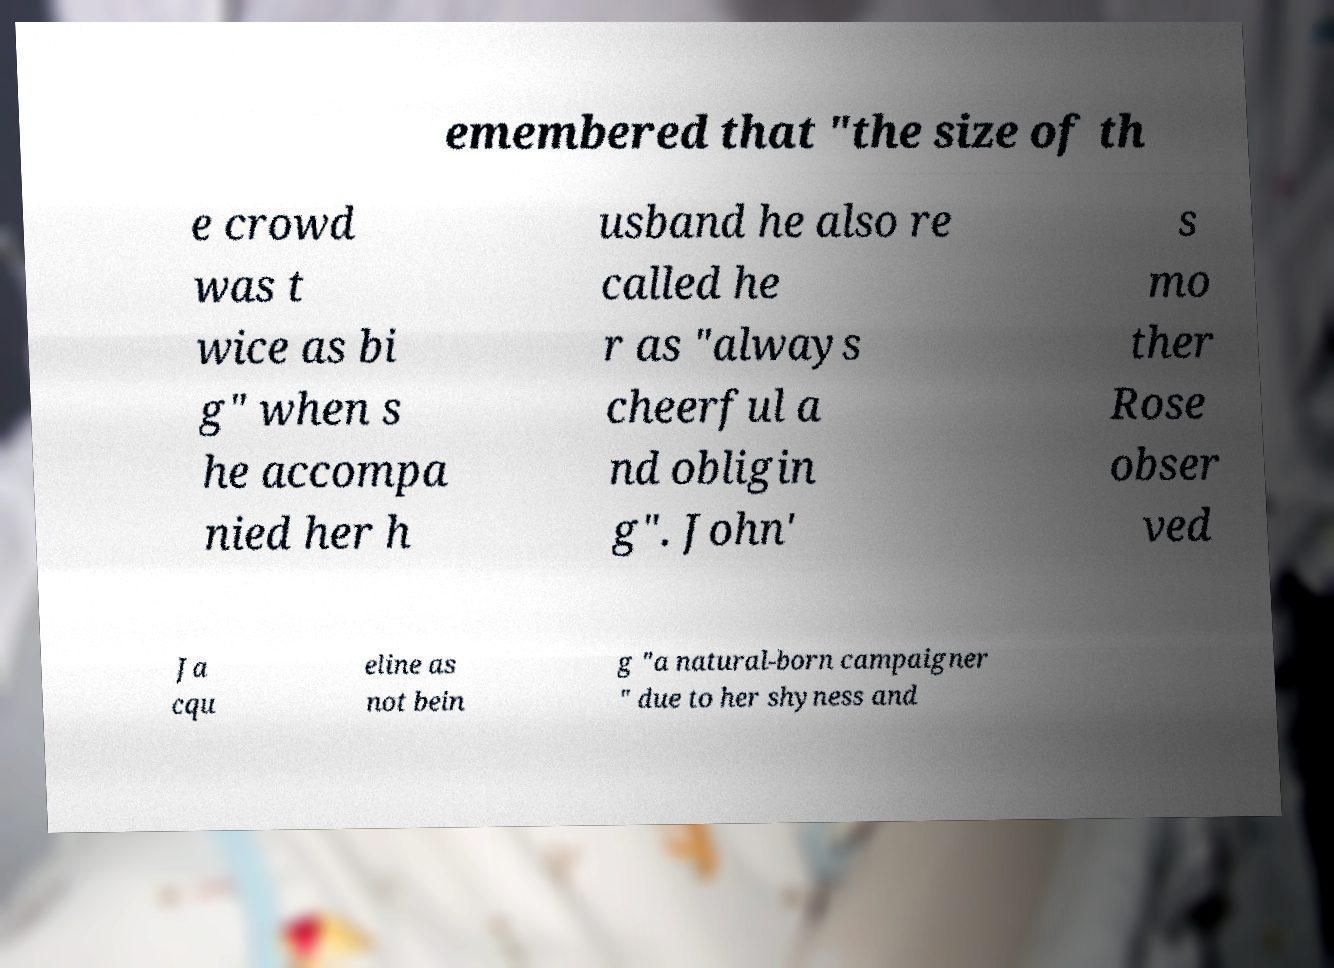Could you assist in decoding the text presented in this image and type it out clearly? emembered that "the size of th e crowd was t wice as bi g" when s he accompa nied her h usband he also re called he r as "always cheerful a nd obligin g". John' s mo ther Rose obser ved Ja cqu eline as not bein g "a natural-born campaigner " due to her shyness and 